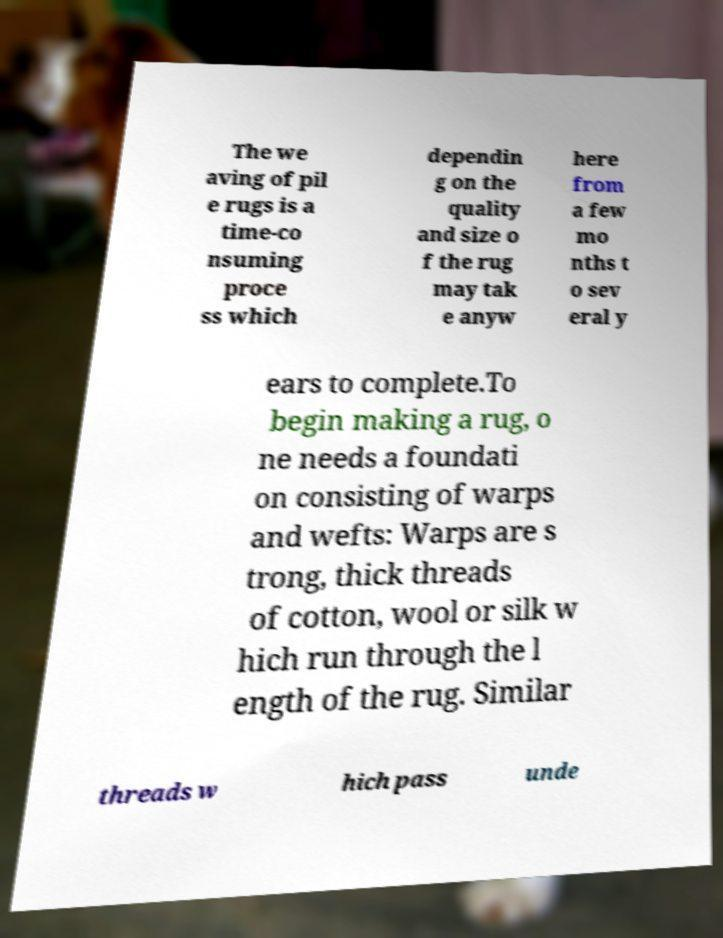Can you accurately transcribe the text from the provided image for me? The we aving of pil e rugs is a time-co nsuming proce ss which dependin g on the quality and size o f the rug may tak e anyw here from a few mo nths t o sev eral y ears to complete.To begin making a rug, o ne needs a foundati on consisting of warps and wefts: Warps are s trong, thick threads of cotton, wool or silk w hich run through the l ength of the rug. Similar threads w hich pass unde 